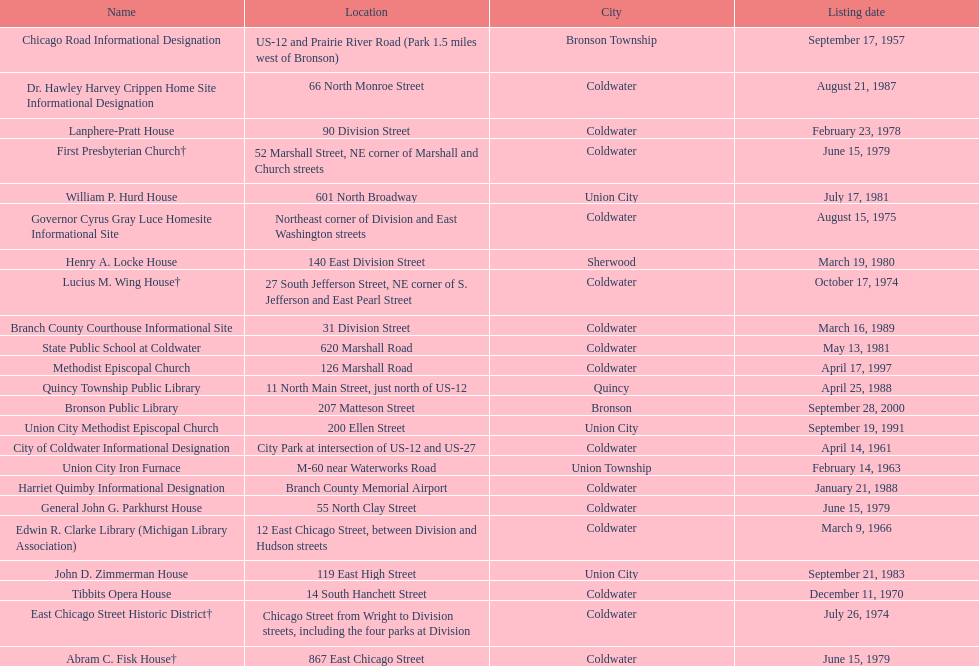Name a site that was listed no later than 1960. Chicago Road Informational Designation. 